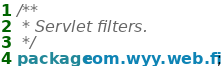Convert code to text. <code><loc_0><loc_0><loc_500><loc_500><_Java_>/**
 * Servlet filters.
 */
package com.wyy.web.filter;
</code> 